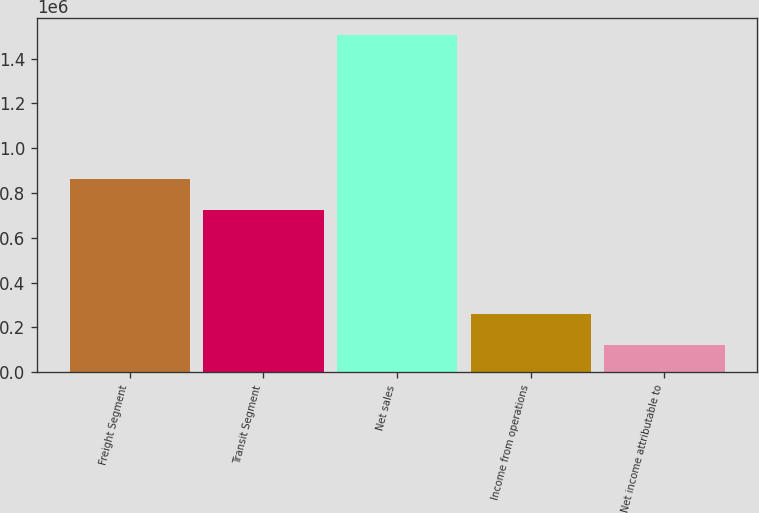Convert chart to OTSL. <chart><loc_0><loc_0><loc_500><loc_500><bar_chart><fcel>Freight Segment<fcel>Transit Segment<fcel>Net sales<fcel>Income from operations<fcel>Net income attributable to<nl><fcel>860899<fcel>722508<fcel>1.50701e+06<fcel>261490<fcel>123099<nl></chart> 